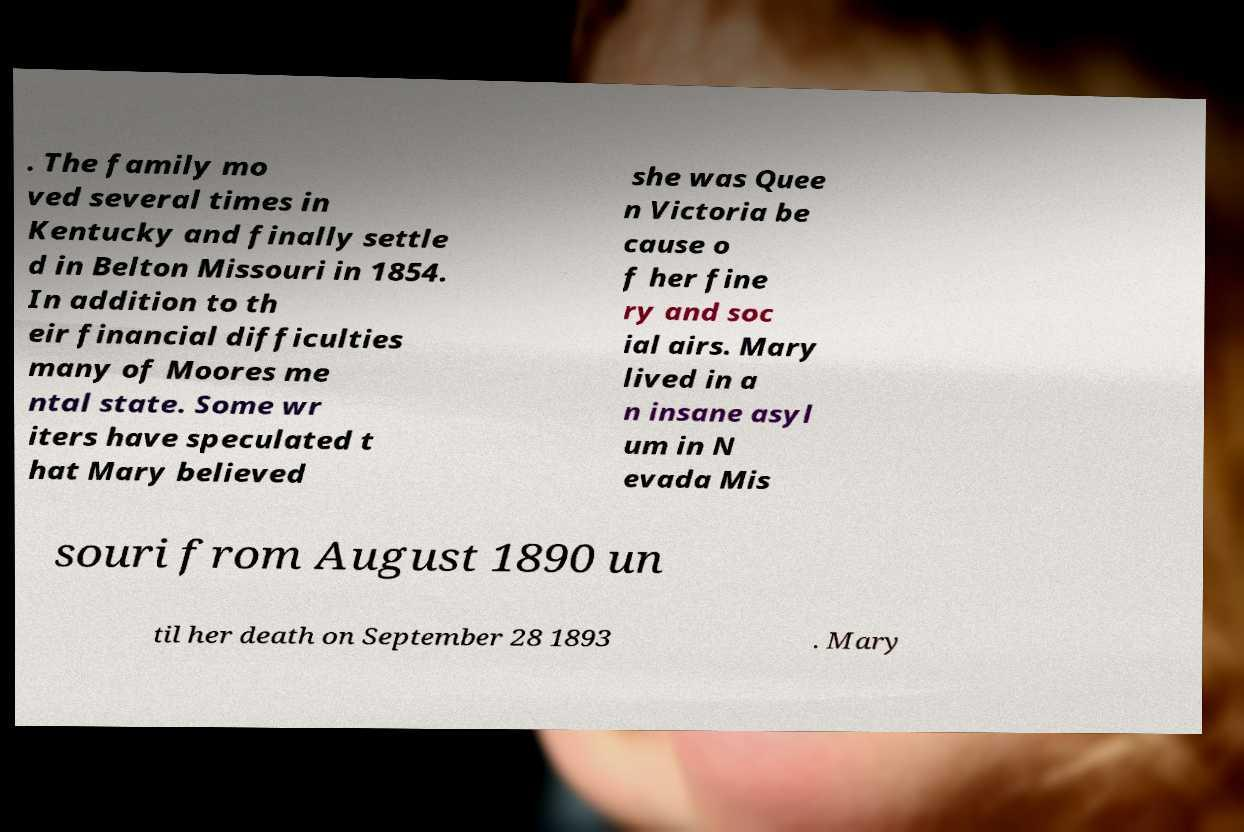Please read and relay the text visible in this image. What does it say? . The family mo ved several times in Kentucky and finally settle d in Belton Missouri in 1854. In addition to th eir financial difficulties many of Moores me ntal state. Some wr iters have speculated t hat Mary believed she was Quee n Victoria be cause o f her fine ry and soc ial airs. Mary lived in a n insane asyl um in N evada Mis souri from August 1890 un til her death on September 28 1893 . Mary 